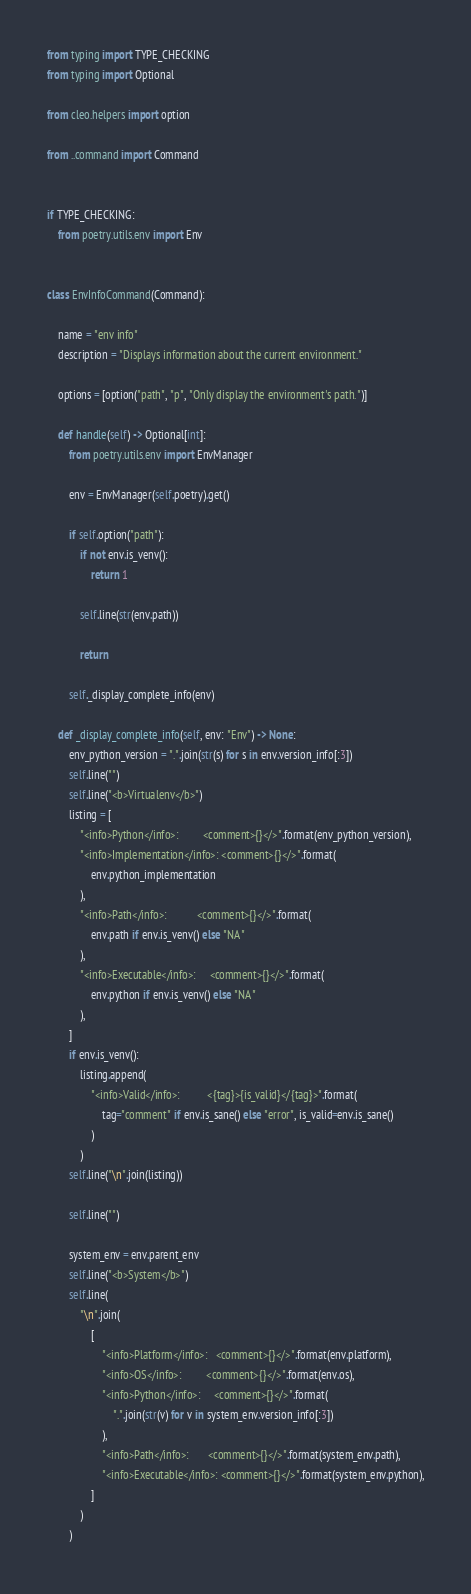<code> <loc_0><loc_0><loc_500><loc_500><_Python_>from typing import TYPE_CHECKING
from typing import Optional

from cleo.helpers import option

from ..command import Command


if TYPE_CHECKING:
    from poetry.utils.env import Env


class EnvInfoCommand(Command):

    name = "env info"
    description = "Displays information about the current environment."

    options = [option("path", "p", "Only display the environment's path.")]

    def handle(self) -> Optional[int]:
        from poetry.utils.env import EnvManager

        env = EnvManager(self.poetry).get()

        if self.option("path"):
            if not env.is_venv():
                return 1

            self.line(str(env.path))

            return

        self._display_complete_info(env)

    def _display_complete_info(self, env: "Env") -> None:
        env_python_version = ".".join(str(s) for s in env.version_info[:3])
        self.line("")
        self.line("<b>Virtualenv</b>")
        listing = [
            "<info>Python</info>:         <comment>{}</>".format(env_python_version),
            "<info>Implementation</info>: <comment>{}</>".format(
                env.python_implementation
            ),
            "<info>Path</info>:           <comment>{}</>".format(
                env.path if env.is_venv() else "NA"
            ),
            "<info>Executable</info>:     <comment>{}</>".format(
                env.python if env.is_venv() else "NA"
            ),
        ]
        if env.is_venv():
            listing.append(
                "<info>Valid</info>:          <{tag}>{is_valid}</{tag}>".format(
                    tag="comment" if env.is_sane() else "error", is_valid=env.is_sane()
                )
            )
        self.line("\n".join(listing))

        self.line("")

        system_env = env.parent_env
        self.line("<b>System</b>")
        self.line(
            "\n".join(
                [
                    "<info>Platform</info>:   <comment>{}</>".format(env.platform),
                    "<info>OS</info>:         <comment>{}</>".format(env.os),
                    "<info>Python</info>:     <comment>{}</>".format(
                        ".".join(str(v) for v in system_env.version_info[:3])
                    ),
                    "<info>Path</info>:       <comment>{}</>".format(system_env.path),
                    "<info>Executable</info>: <comment>{}</>".format(system_env.python),
                ]
            )
        )
</code> 